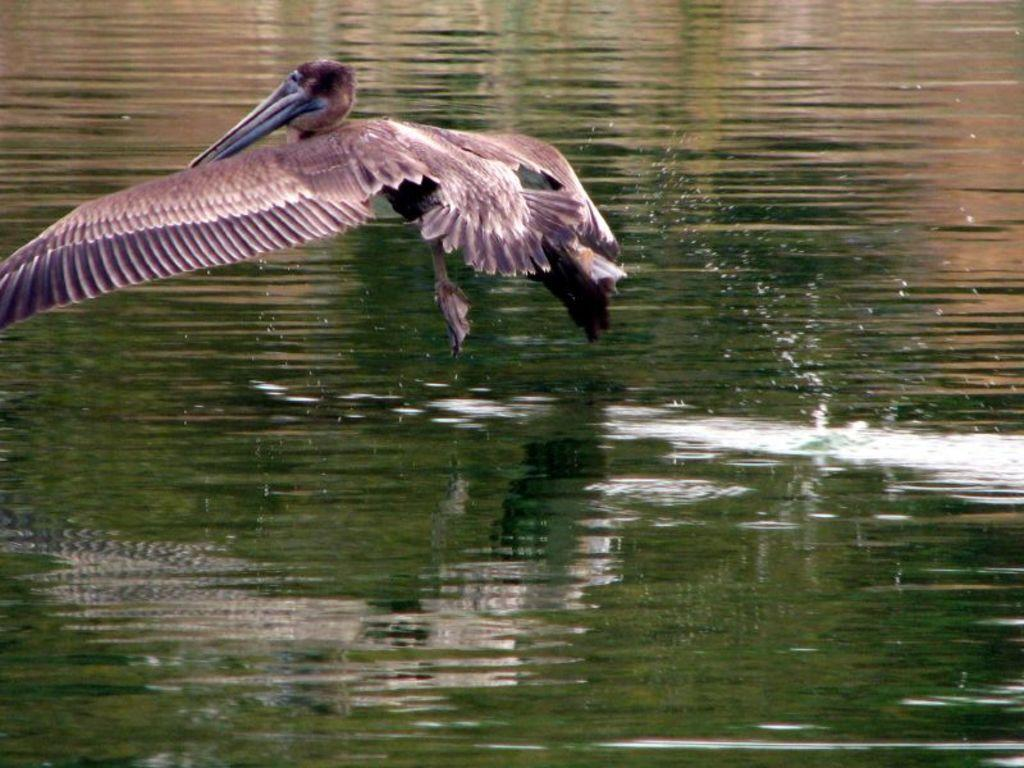What is the main subject of the image? The main subject of the image is a bird flying. What can be seen in the background of the image? There is water visible in the image. What type of rock can be seen on top of the bird in the image? There is no rock present in the image, and the bird is not on top of any object. 